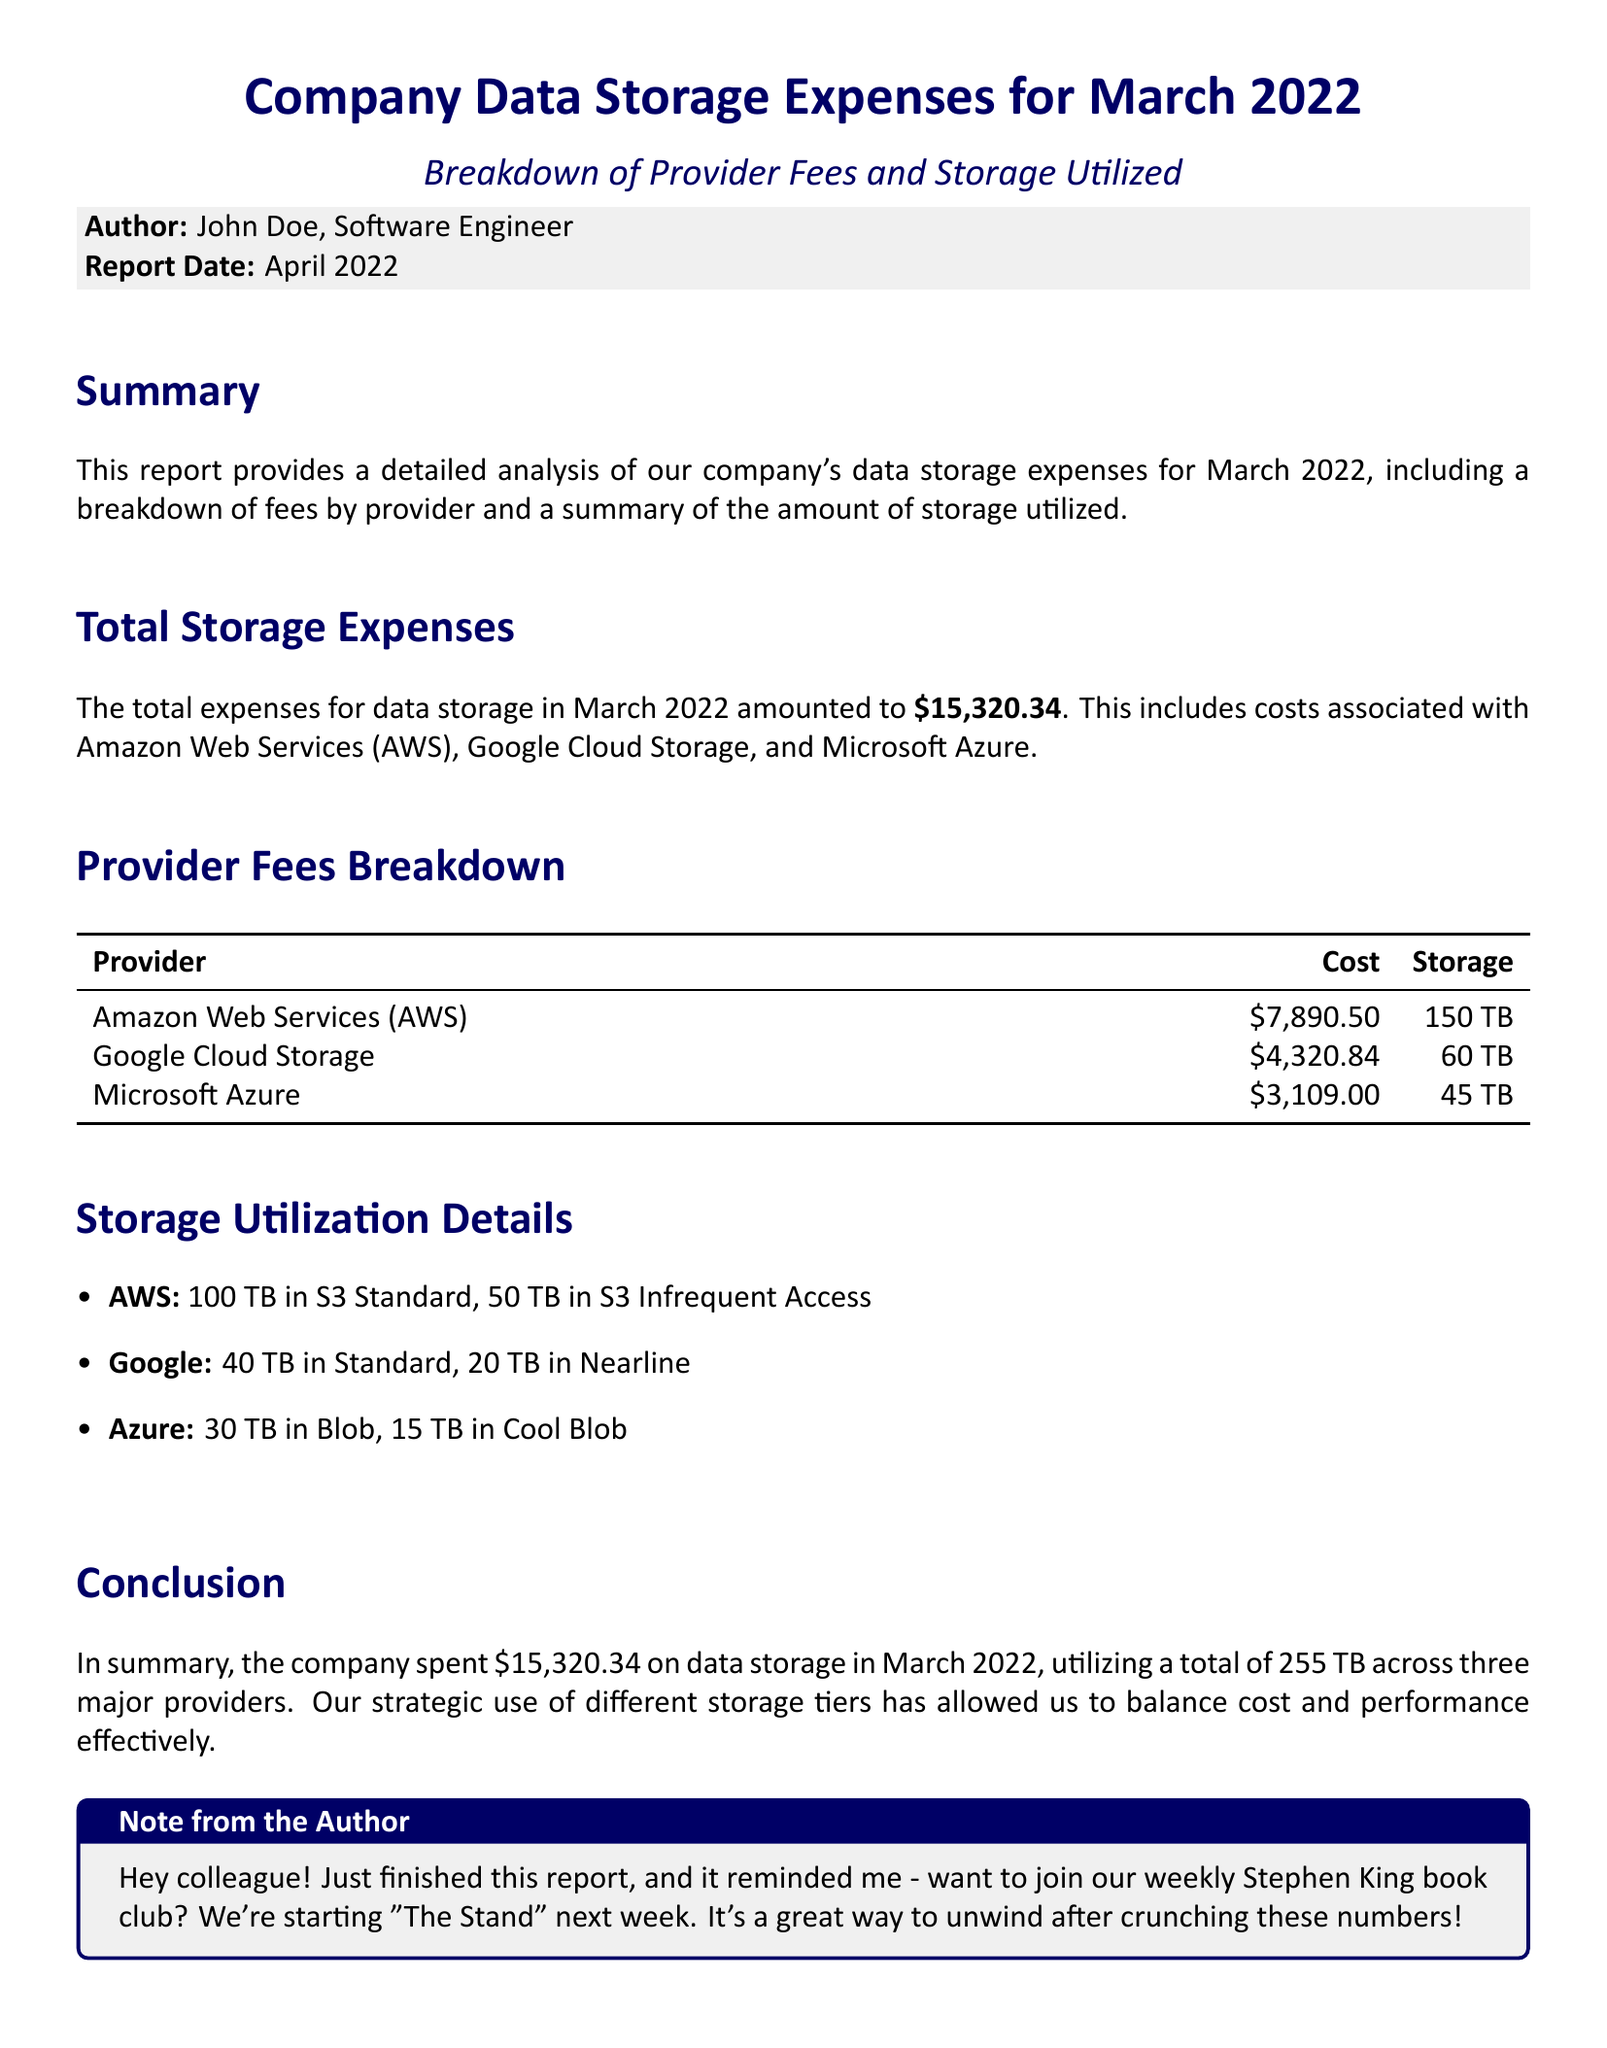What is the total expense for data storage in March 2022? The total expense amount for data storage is explicitly stated in the document as $15,320.34.
Answer: $15,320.34 How much did Amazon Web Services (AWS) cost? The document specifies the cost associated with AWS, which is detailed in the Provider Fees Breakdown section as $7,890.50.
Answer: $7,890.50 What is the total storage utilized across all providers? The total storage utilized combines the storage amounts listed for each provider, resulting in 255 TB.
Answer: 255 TB Which provider had the least storage utilized? The storage utilization details indicate that Microsoft Azure had the least storage utilized at 45 TB.
Answer: Microsoft Azure What percentage of the total expenses is attributed to Google Cloud Storage? The cost for Google Cloud Storage is $4,320.84, so the reasoning involves calculating its percentage of the total expenses of $15,320.34, which equals approximately 28.2%.
Answer: 28.2% What is the storage amount for AWS in S3 Standard? The document states that AWS has 100 TB allocated in S3 Standard storage.
Answer: 100 TB Who authored the report? The author of the report is mentioned in the header of the summary section as John Doe.
Answer: John Doe What is the report date? The report date is provided in the document as April 2022, indicating when the report was created.
Answer: April 2022 What is the storage type for Google Cloud’s Nearline? The storage utilized in Google Cloud Storage includes 20 TB in Nearline, mentioned in the Storage Utilization Details.
Answer: Nearline 